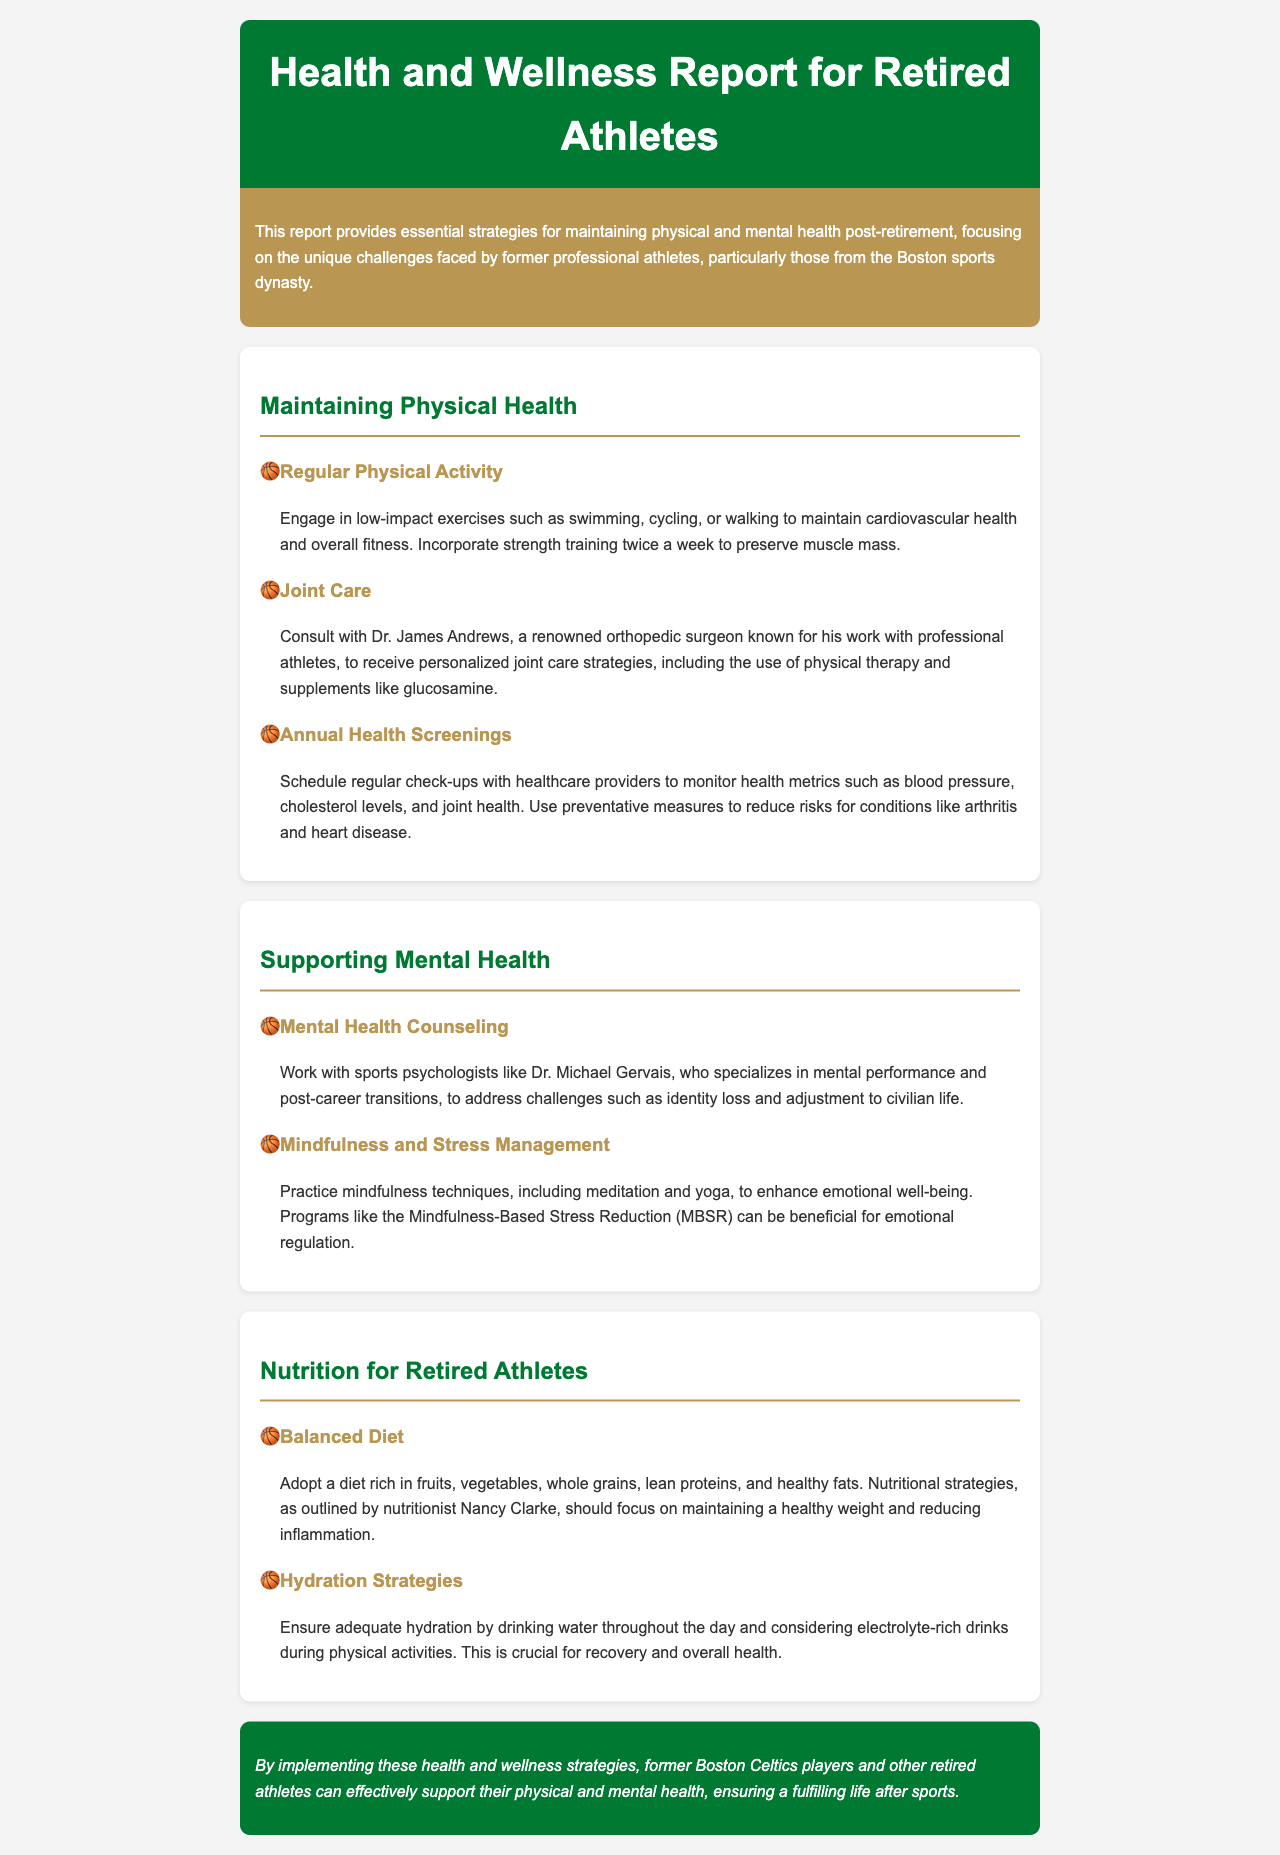what is the title of the report? The title of the report is the main heading found at the top of the document.
Answer: Health and Wellness Report for Retired Athletes who is the orthopedic surgeon mentioned for joint care? The orthopedic surgeon known for his work with professional athletes is mentioned in the joint care section.
Answer: Dr. James Andrews how often should retired athletes schedule health screenings? This detail can be found in the annual health screenings section.
Answer: Regularly what are two recommended low-impact exercises? Low-impact exercises listed in the report promote cardiovascular health and fitness.
Answer: Swimming, cycling who specializes in mental performance and post-career transitions? This person is mentioned in the mental health counseling section of the document.
Answer: Dr. Michael Gervais what diet is recommended for retired athletes? The diet recommendation indicates a healthy eating focus detailed in the nutrition section.
Answer: Balanced diet what mindfulness program can benefit emotional regulation? This program is referenced in the mindfulness and stress management section.
Answer: Mindfulness-Based Stress Reduction (MBSR) how many times a week should strength training be incorporated? The frequency of strength training sessions is specified in the physical health section.
Answer: Twice a week what is one strategy for maintaining adequate hydration? The hydration strategies section outlines a method for staying hydrated.
Answer: Drinking water throughout the day 